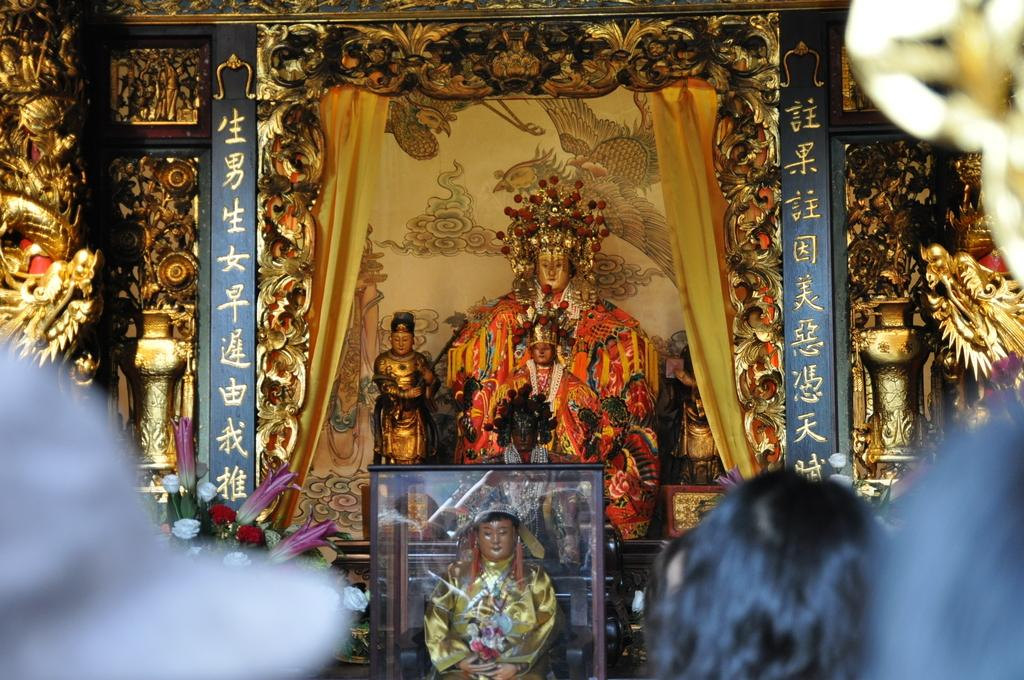Who or what can be seen in the image? There are people in the image. What can be seen in the background of the image? There are statues, sculptures, and flowers in the background of the image. Is there any indication of a frame in the image? Yes, there is a frame visible in the image. What type of list is being discussed by the people in the image? There is no list present in the image, nor is there any indication of a discussion about a list. 